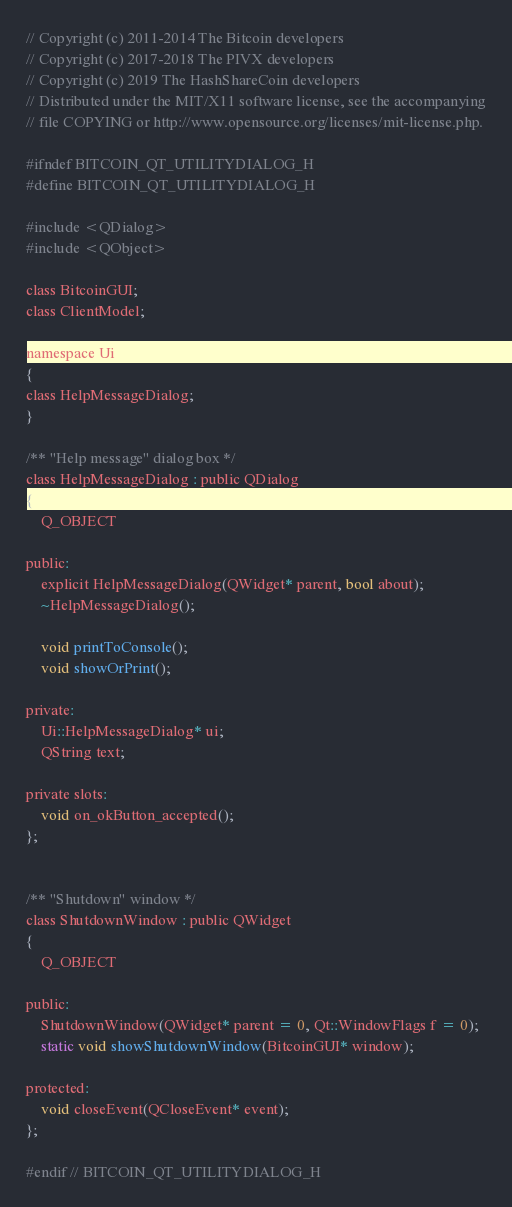<code> <loc_0><loc_0><loc_500><loc_500><_C_>// Copyright (c) 2011-2014 The Bitcoin developers
// Copyright (c) 2017-2018 The PIVX developers
// Copyright (c) 2019 The HashShareCoin developers
// Distributed under the MIT/X11 software license, see the accompanying
// file COPYING or http://www.opensource.org/licenses/mit-license.php.

#ifndef BITCOIN_QT_UTILITYDIALOG_H
#define BITCOIN_QT_UTILITYDIALOG_H

#include <QDialog>
#include <QObject>

class BitcoinGUI;
class ClientModel;

namespace Ui
{
class HelpMessageDialog;
}

/** "Help message" dialog box */
class HelpMessageDialog : public QDialog
{
    Q_OBJECT

public:
    explicit HelpMessageDialog(QWidget* parent, bool about);
    ~HelpMessageDialog();

    void printToConsole();
    void showOrPrint();

private:
    Ui::HelpMessageDialog* ui;
    QString text;

private slots:
    void on_okButton_accepted();
};


/** "Shutdown" window */
class ShutdownWindow : public QWidget
{
    Q_OBJECT

public:
    ShutdownWindow(QWidget* parent = 0, Qt::WindowFlags f = 0);
    static void showShutdownWindow(BitcoinGUI* window);

protected:
    void closeEvent(QCloseEvent* event);
};

#endif // BITCOIN_QT_UTILITYDIALOG_H
</code> 